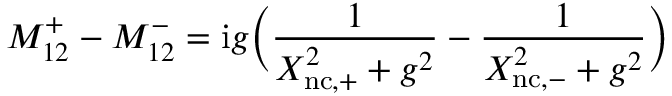<formula> <loc_0><loc_0><loc_500><loc_500>M _ { 1 2 } ^ { + } - M _ { 1 2 } ^ { - } = i g \left ( \frac { 1 } { X _ { n c , + } ^ { 2 } + g ^ { 2 } } - \frac { 1 } { X _ { n c , - } ^ { 2 } + g ^ { 2 } } \right )</formula> 